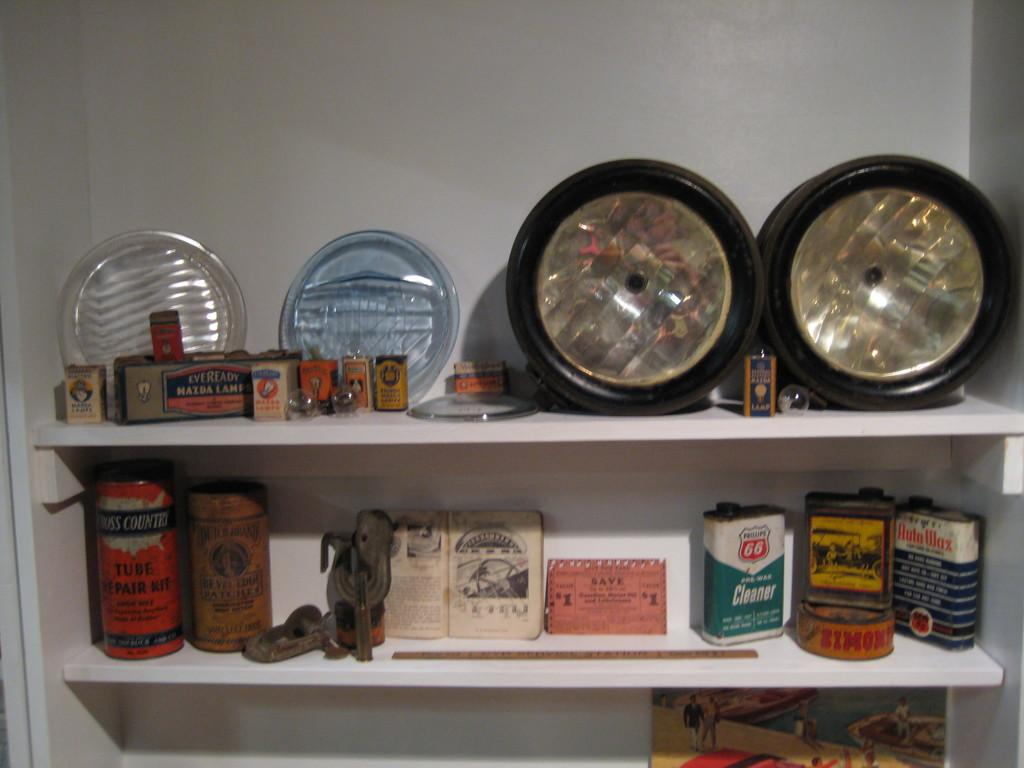What can be found on the shelves in the image? There are things on the shelves in the image. Can you identify any specific item on the shelves? There is a book in the image. What color is the wall in the image? The wall in the image is white. How many bottles are on the shelves in the image? There is no mention of bottles in the provided facts, so we cannot determine the number of bottles on the shelves. Can you see a kitty playing with a dog in the image? There is no mention of a kitty or a dog in the provided facts, so we cannot see them in the image. 